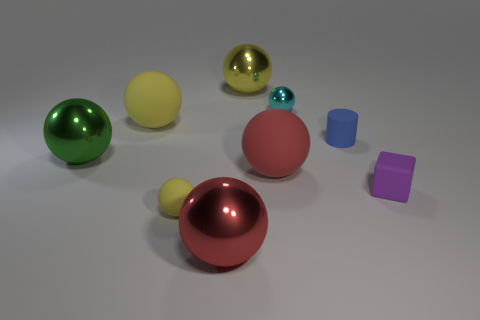There is a green thing that is the same shape as the big yellow matte object; what is its material?
Your answer should be compact. Metal. Is there any other thing that has the same material as the cyan thing?
Keep it short and to the point. Yes. What is the color of the tiny shiny object?
Your answer should be very brief. Cyan. Does the tiny rubber cube have the same color as the tiny metal ball?
Your answer should be compact. No. What number of things are to the right of the big yellow ball that is to the right of the tiny yellow ball?
Give a very brief answer. 4. What is the size of the metallic sphere that is on the right side of the big red shiny thing and on the left side of the cyan metallic thing?
Keep it short and to the point. Large. There is a small object that is to the right of the tiny blue rubber cylinder; what material is it?
Keep it short and to the point. Rubber. Is there a small purple object of the same shape as the large yellow matte thing?
Offer a terse response. No. How many big red matte things have the same shape as the blue thing?
Give a very brief answer. 0. Do the yellow matte thing that is in front of the green metallic thing and the yellow ball that is behind the small cyan thing have the same size?
Give a very brief answer. No. 